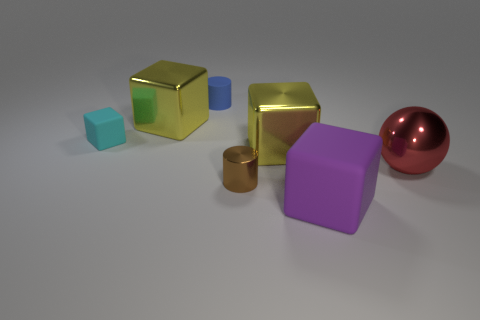What number of objects are shiny cubes or cubes that are behind the large red thing?
Your response must be concise. 3. There is a small cyan object that is the same shape as the purple thing; what is its material?
Offer a terse response. Rubber. Are there any other things that are the same material as the tiny cyan object?
Ensure brevity in your answer.  Yes. The large cube that is behind the metallic cylinder and on the right side of the metallic cylinder is made of what material?
Ensure brevity in your answer.  Metal. How many big red things are the same shape as the blue rubber object?
Offer a very short reply. 0. What is the color of the tiny thing that is behind the small matte object to the left of the blue object?
Offer a terse response. Blue. Is the number of matte cylinders that are behind the blue matte thing the same as the number of cyan shiny objects?
Offer a terse response. Yes. Is there a rubber object of the same size as the brown cylinder?
Keep it short and to the point. Yes. There is a red metal thing; is its size the same as the yellow metallic cube in front of the tiny rubber block?
Your answer should be very brief. Yes. Are there the same number of matte cubes on the left side of the big red shiny ball and cyan objects behind the small cyan matte cube?
Offer a terse response. No. 